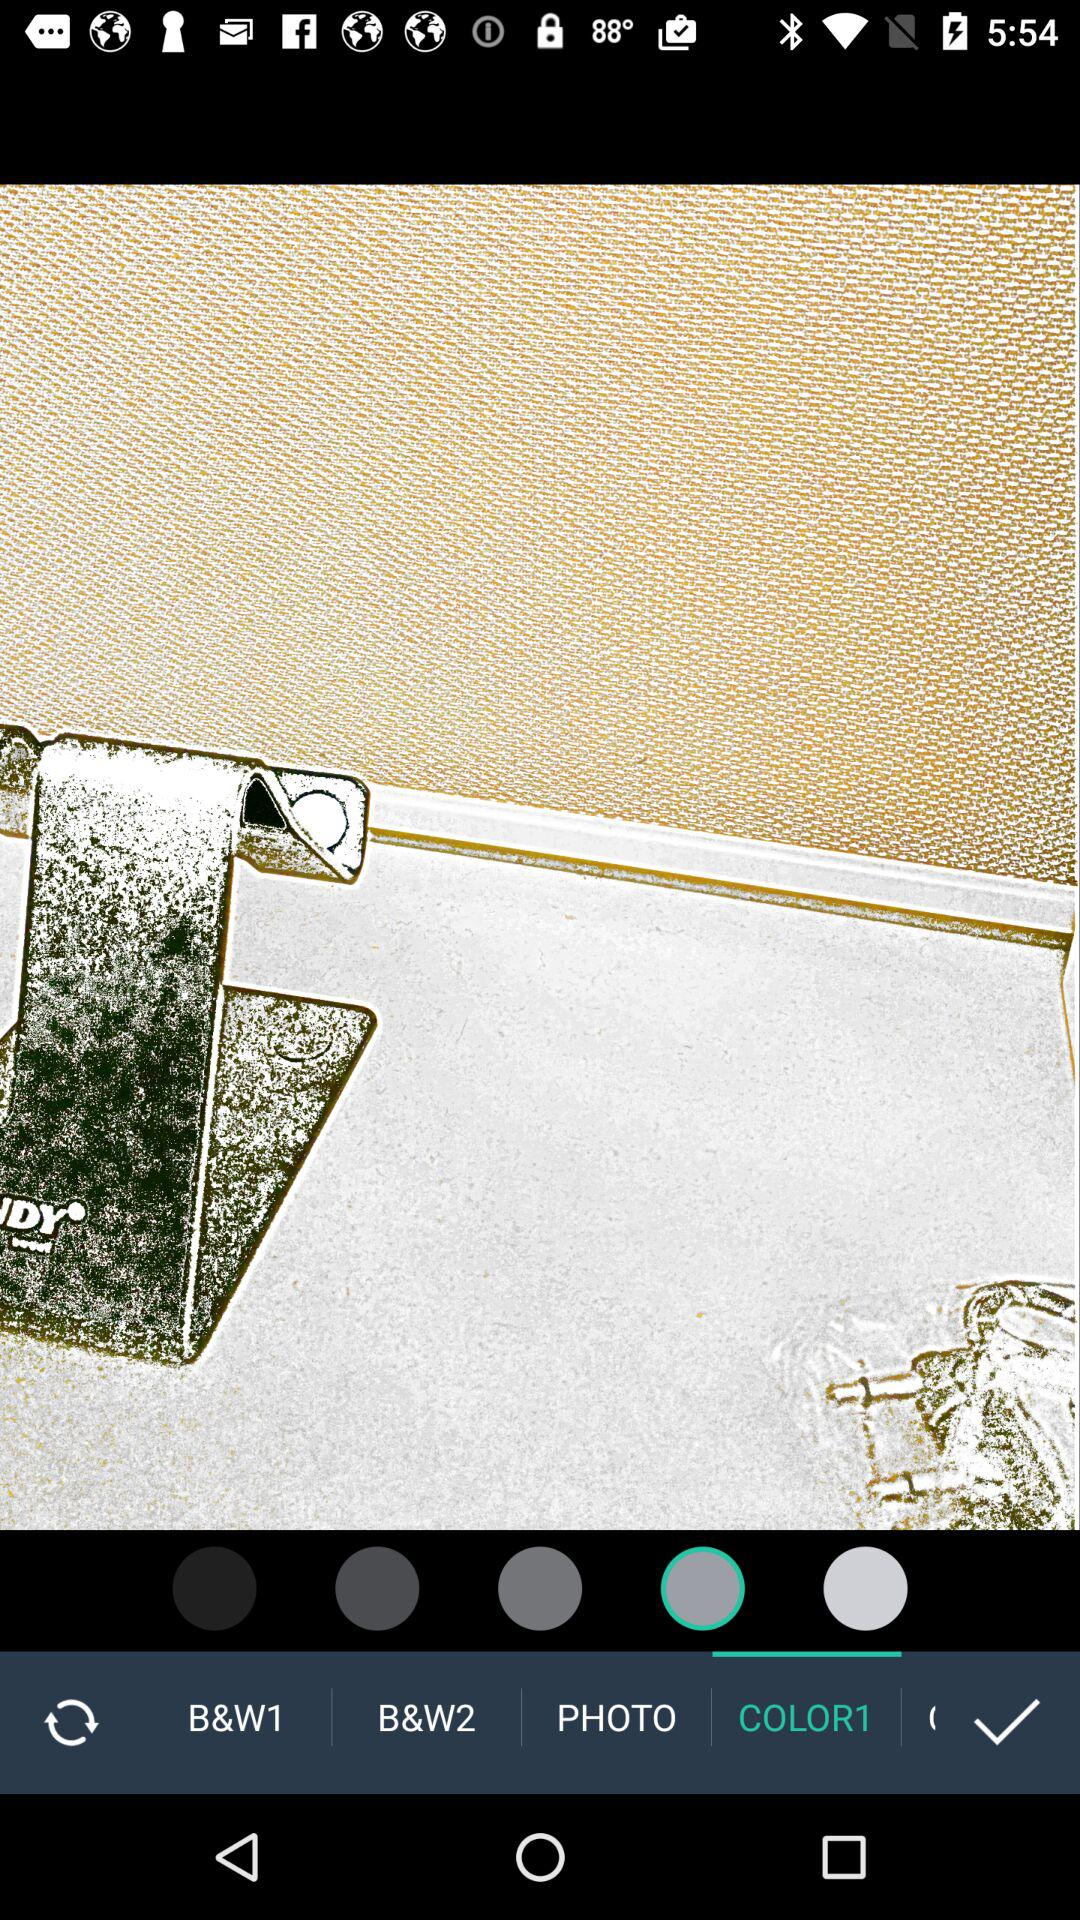Which option is selected? The selected option is "COLOR1". 